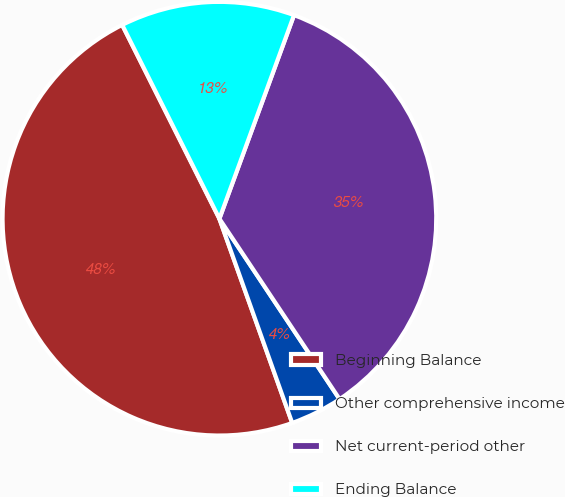<chart> <loc_0><loc_0><loc_500><loc_500><pie_chart><fcel>Beginning Balance<fcel>Other comprehensive income<fcel>Net current-period other<fcel>Ending Balance<nl><fcel>48.05%<fcel>3.9%<fcel>35.06%<fcel>12.99%<nl></chart> 